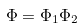Convert formula to latex. <formula><loc_0><loc_0><loc_500><loc_500>\Phi = \Phi _ { 1 } \Phi _ { 2 }</formula> 